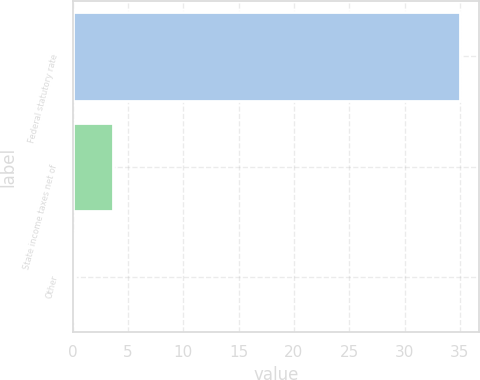Convert chart. <chart><loc_0><loc_0><loc_500><loc_500><bar_chart><fcel>Federal statutory rate<fcel>State income taxes net of<fcel>Other<nl><fcel>35<fcel>3.68<fcel>0.2<nl></chart> 